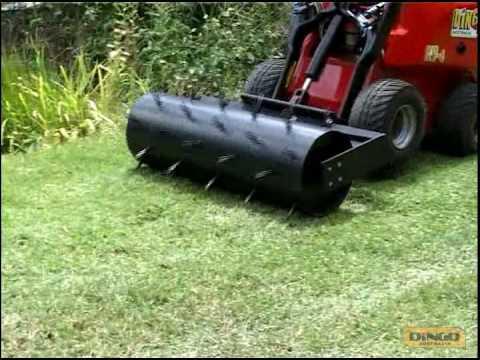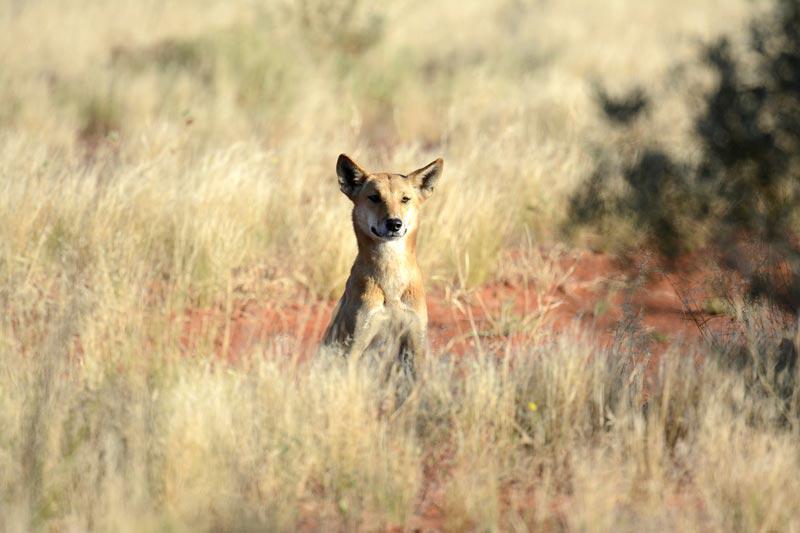The first image is the image on the left, the second image is the image on the right. Given the left and right images, does the statement "There are two dogs in total." hold true? Answer yes or no. No. 